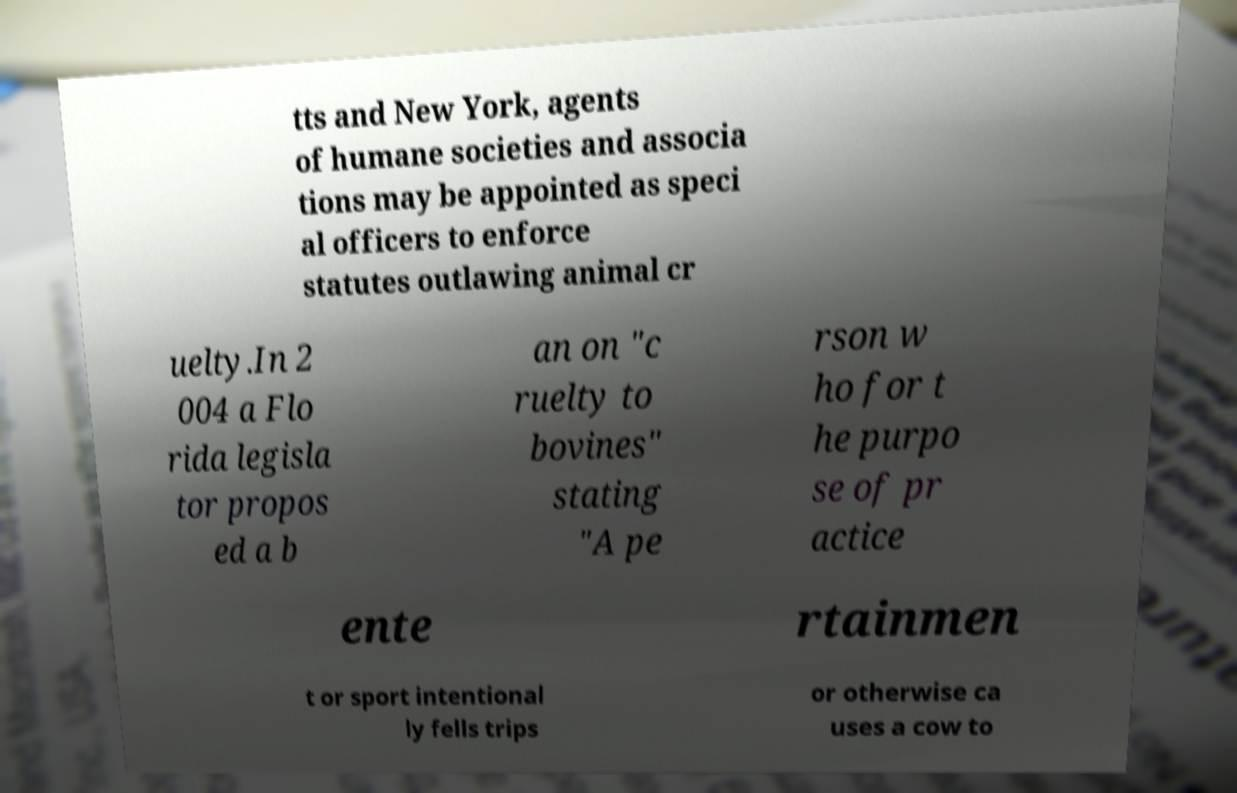There's text embedded in this image that I need extracted. Can you transcribe it verbatim? tts and New York, agents of humane societies and associa tions may be appointed as speci al officers to enforce statutes outlawing animal cr uelty.In 2 004 a Flo rida legisla tor propos ed a b an on "c ruelty to bovines" stating "A pe rson w ho for t he purpo se of pr actice ente rtainmen t or sport intentional ly fells trips or otherwise ca uses a cow to 